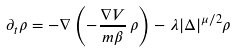Convert formula to latex. <formula><loc_0><loc_0><loc_500><loc_500>\partial _ { t } \rho = - \nabla \left ( - { \frac { \nabla V } { m \beta } } \, \rho \right ) - \lambda | \Delta | ^ { \mu / 2 } \rho</formula> 